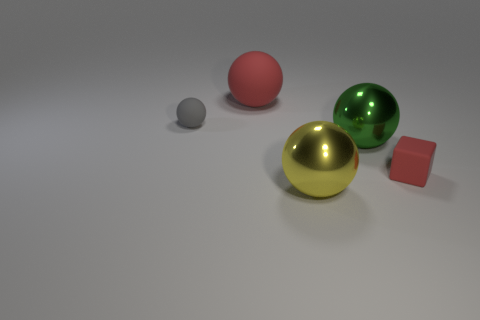Add 1 metal balls. How many objects exist? 6 Subtract all cubes. How many objects are left? 4 Add 3 big red objects. How many big red objects exist? 4 Subtract 0 red cylinders. How many objects are left? 5 Subtract all cyan cubes. Subtract all large green objects. How many objects are left? 4 Add 3 large matte balls. How many large matte balls are left? 4 